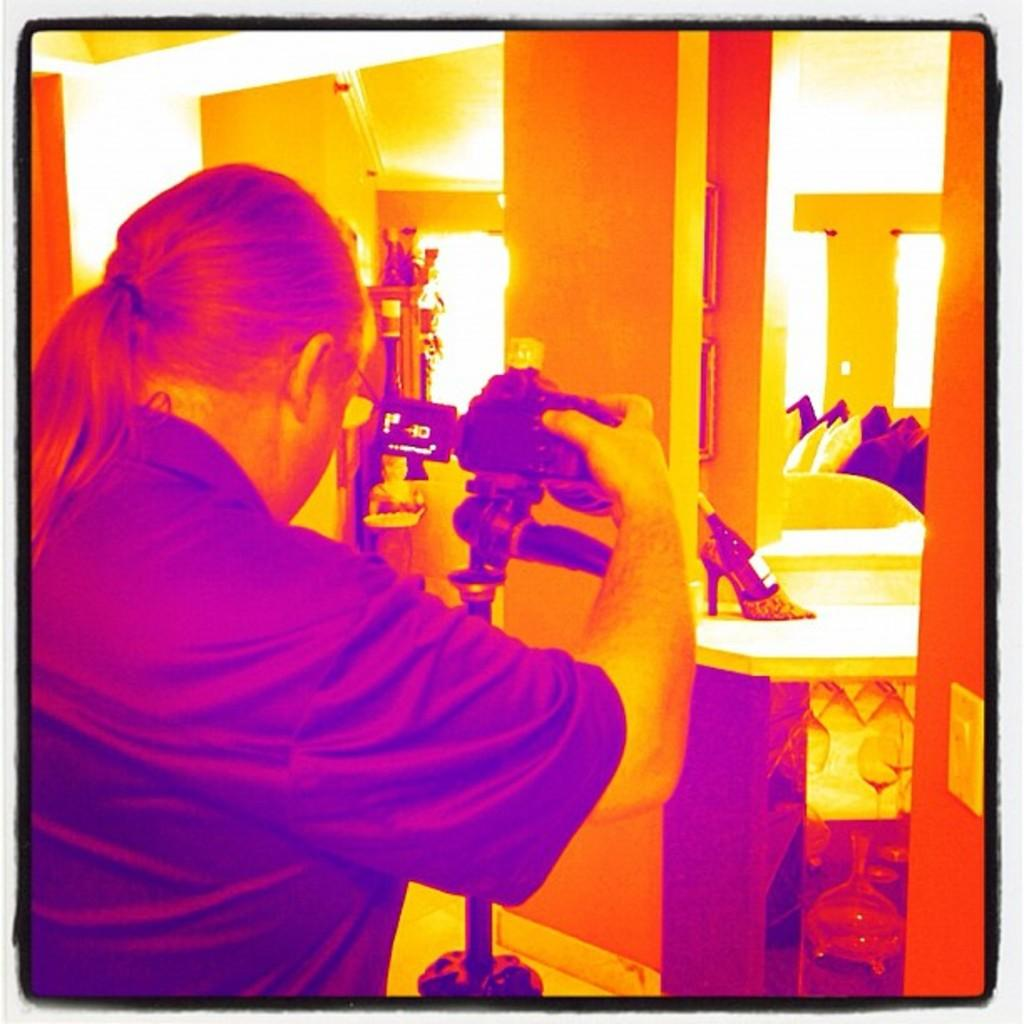What is the person in the image holding? The person in the image is holding a camera stand. What can be seen in the background of the image? There are objects in the background of the image. What type of seating is present in the image? Cushions are present in the image. What is placed on the camera stand? There is a sandal on the camera stand. What type of regret is expressed by the person holding the camera stand in the image? There is no indication of regret in the image; the person is simply holding a camera stand. 